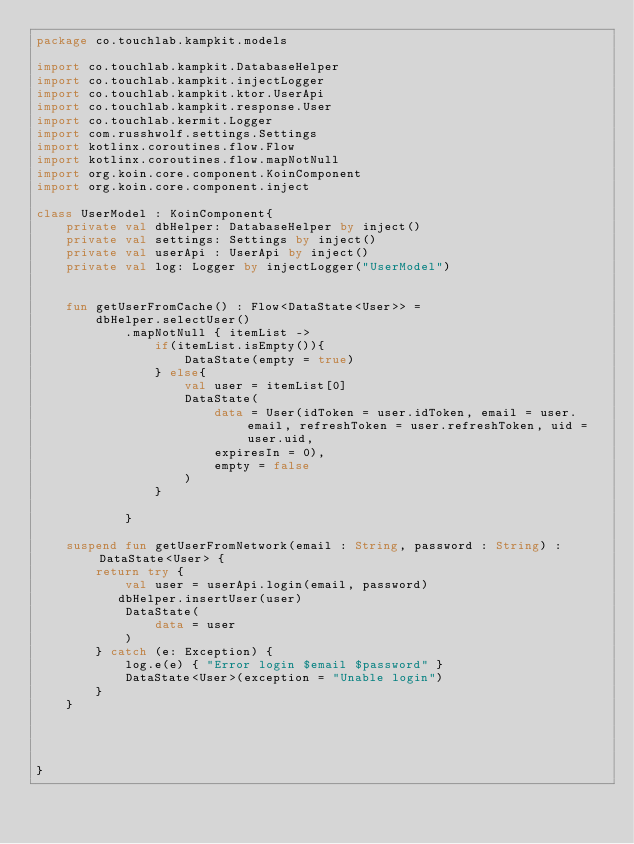Convert code to text. <code><loc_0><loc_0><loc_500><loc_500><_Kotlin_>package co.touchlab.kampkit.models

import co.touchlab.kampkit.DatabaseHelper
import co.touchlab.kampkit.injectLogger
import co.touchlab.kampkit.ktor.UserApi
import co.touchlab.kampkit.response.User
import co.touchlab.kermit.Logger
import com.russhwolf.settings.Settings
import kotlinx.coroutines.flow.Flow
import kotlinx.coroutines.flow.mapNotNull
import org.koin.core.component.KoinComponent
import org.koin.core.component.inject

class UserModel : KoinComponent{
    private val dbHelper: DatabaseHelper by inject()
    private val settings: Settings by inject()
    private val userApi : UserApi by inject()
    private val log: Logger by injectLogger("UserModel")


    fun getUserFromCache() : Flow<DataState<User>> =
        dbHelper.selectUser()
            .mapNotNull { itemList ->
                if(itemList.isEmpty()){
                    DataState(empty = true)
                } else{
                    val user = itemList[0]
                    DataState(
                        data = User(idToken = user.idToken, email = user.email, refreshToken = user.refreshToken, uid = user.uid,
                        expiresIn = 0),
                        empty = false
                    )
                }

            }

    suspend fun getUserFromNetwork(email : String, password : String) :DataState<User> {
        return try {
            val user = userApi.login(email, password)
           dbHelper.insertUser(user)
            DataState(
                data = user
            )
        } catch (e: Exception) {
            log.e(e) { "Error login $email $password" }
            DataState<User>(exception = "Unable login")
        }
    }




}</code> 